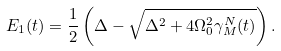Convert formula to latex. <formula><loc_0><loc_0><loc_500><loc_500>E _ { 1 } ( t ) = \frac { 1 } { 2 } \left ( \Delta - \sqrt { \Delta ^ { 2 } + 4 \Omega _ { 0 } ^ { 2 } \gamma _ { M } ^ { N } ( t ) } \right ) .</formula> 